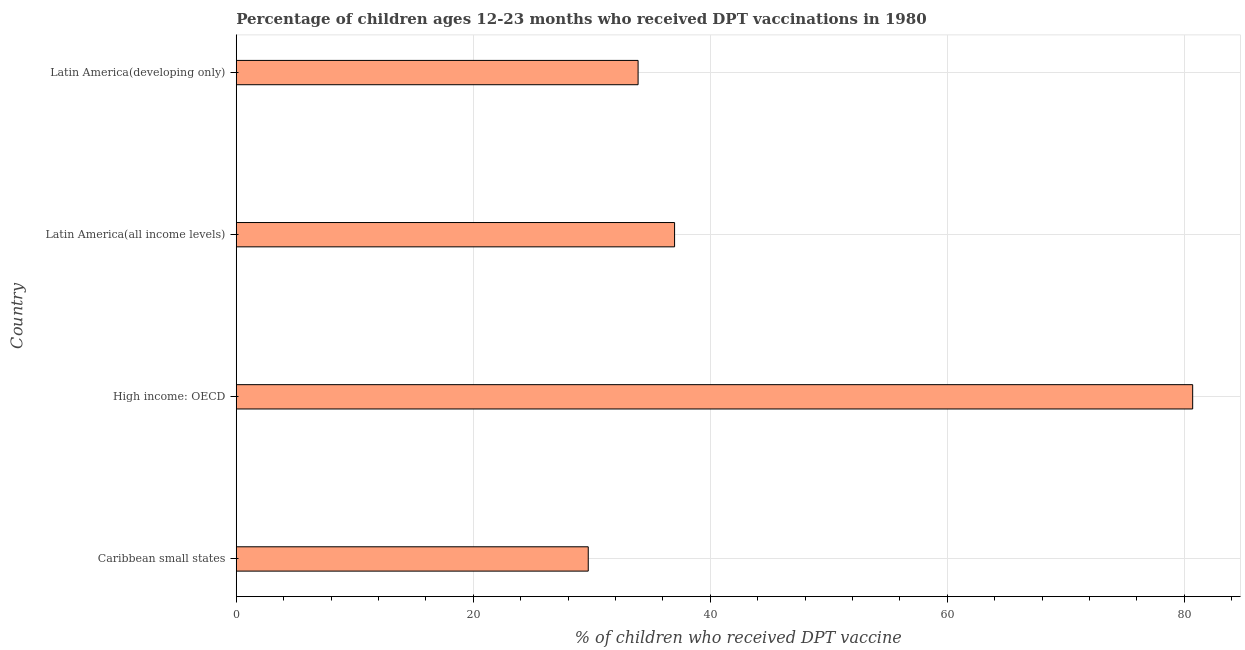Does the graph contain any zero values?
Ensure brevity in your answer.  No. Does the graph contain grids?
Your answer should be very brief. Yes. What is the title of the graph?
Keep it short and to the point. Percentage of children ages 12-23 months who received DPT vaccinations in 1980. What is the label or title of the X-axis?
Your answer should be very brief. % of children who received DPT vaccine. What is the percentage of children who received dpt vaccine in Caribbean small states?
Offer a terse response. 29.71. Across all countries, what is the maximum percentage of children who received dpt vaccine?
Offer a terse response. 80.72. Across all countries, what is the minimum percentage of children who received dpt vaccine?
Offer a very short reply. 29.71. In which country was the percentage of children who received dpt vaccine maximum?
Make the answer very short. High income: OECD. In which country was the percentage of children who received dpt vaccine minimum?
Provide a succinct answer. Caribbean small states. What is the sum of the percentage of children who received dpt vaccine?
Ensure brevity in your answer.  181.32. What is the difference between the percentage of children who received dpt vaccine in Latin America(all income levels) and Latin America(developing only)?
Your answer should be compact. 3.08. What is the average percentage of children who received dpt vaccine per country?
Offer a very short reply. 45.33. What is the median percentage of children who received dpt vaccine?
Your response must be concise. 35.45. In how many countries, is the percentage of children who received dpt vaccine greater than 72 %?
Give a very brief answer. 1. What is the ratio of the percentage of children who received dpt vaccine in Caribbean small states to that in High income: OECD?
Make the answer very short. 0.37. Is the percentage of children who received dpt vaccine in High income: OECD less than that in Latin America(all income levels)?
Give a very brief answer. No. What is the difference between the highest and the second highest percentage of children who received dpt vaccine?
Ensure brevity in your answer.  43.72. What is the difference between the highest and the lowest percentage of children who received dpt vaccine?
Keep it short and to the point. 51.01. In how many countries, is the percentage of children who received dpt vaccine greater than the average percentage of children who received dpt vaccine taken over all countries?
Make the answer very short. 1. How many bars are there?
Give a very brief answer. 4. What is the difference between two consecutive major ticks on the X-axis?
Offer a terse response. 20. Are the values on the major ticks of X-axis written in scientific E-notation?
Offer a very short reply. No. What is the % of children who received DPT vaccine in Caribbean small states?
Make the answer very short. 29.71. What is the % of children who received DPT vaccine of High income: OECD?
Your answer should be very brief. 80.72. What is the % of children who received DPT vaccine in Latin America(all income levels)?
Provide a succinct answer. 36.99. What is the % of children who received DPT vaccine of Latin America(developing only)?
Provide a succinct answer. 33.91. What is the difference between the % of children who received DPT vaccine in Caribbean small states and High income: OECD?
Ensure brevity in your answer.  -51.01. What is the difference between the % of children who received DPT vaccine in Caribbean small states and Latin America(all income levels)?
Make the answer very short. -7.29. What is the difference between the % of children who received DPT vaccine in Caribbean small states and Latin America(developing only)?
Your answer should be compact. -4.21. What is the difference between the % of children who received DPT vaccine in High income: OECD and Latin America(all income levels)?
Provide a short and direct response. 43.72. What is the difference between the % of children who received DPT vaccine in High income: OECD and Latin America(developing only)?
Ensure brevity in your answer.  46.8. What is the difference between the % of children who received DPT vaccine in Latin America(all income levels) and Latin America(developing only)?
Keep it short and to the point. 3.08. What is the ratio of the % of children who received DPT vaccine in Caribbean small states to that in High income: OECD?
Provide a short and direct response. 0.37. What is the ratio of the % of children who received DPT vaccine in Caribbean small states to that in Latin America(all income levels)?
Make the answer very short. 0.8. What is the ratio of the % of children who received DPT vaccine in Caribbean small states to that in Latin America(developing only)?
Your response must be concise. 0.88. What is the ratio of the % of children who received DPT vaccine in High income: OECD to that in Latin America(all income levels)?
Provide a short and direct response. 2.18. What is the ratio of the % of children who received DPT vaccine in High income: OECD to that in Latin America(developing only)?
Your answer should be compact. 2.38. What is the ratio of the % of children who received DPT vaccine in Latin America(all income levels) to that in Latin America(developing only)?
Keep it short and to the point. 1.09. 